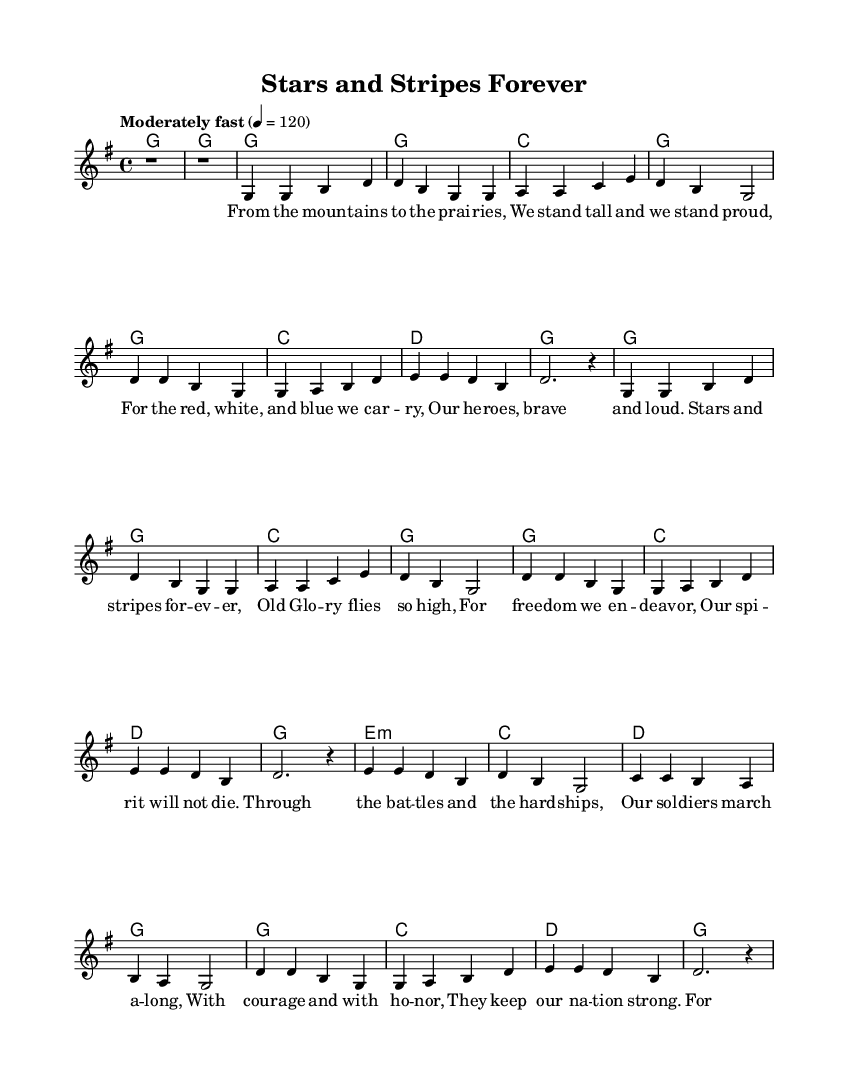What is the key signature of this music? The key signature is G major, which has one sharp (F#). This can be identified by looking at the key signature placed at the beginning of the staff, which indicates G major.
Answer: G major What is the time signature of this piece? The time signature is 4/4, as indicated at the beginning of the score. This means there are four beats per measure, and a quarter note receives one beat.
Answer: 4/4 What is the tempo marking of this music? The tempo marking is "Moderately fast" with a metronome marking of 120, which is stated at the beginning of the score. This provides the performer an idea of how quickly the piece should be played.
Answer: Moderately fast How many verses are present in this sheet music? The piece contains two verses, which can be noted from the structure of the lyrics where "Verse 1" and "Verse 2" are labeled. Each section comprises lyrics that relate to the themes of military service and sacrifice.
Answer: Two What is the main theme of the lyrics? The main theme of the lyrics celebrates military service and sacrifice, highlighting bravery, honor, and remembrance of fallen soldiers. This is derived from the lyrical content that discusses the pride in serving the nation and honoring those who have sacrificed.
Answer: Military service and sacrifice What musical section follows the first chorus? The musical section that follows the first chorus is "Verse 2". This can be understood by analyzing the structure of the piece, where after completing the first chorus, the next section labeled is Verse 2.
Answer: Verse 2 How is the bridge section characterized in the lyrics? The bridge section is characterized by a somber reflection on sacrifice by those who served, indicating a moment of solemnity and remembrance, which is distinct from the more celebratory verses and chorus. This can be noted from the lyrics labeled as "Bridge" that express these themes.
Answer: Somber reflection 